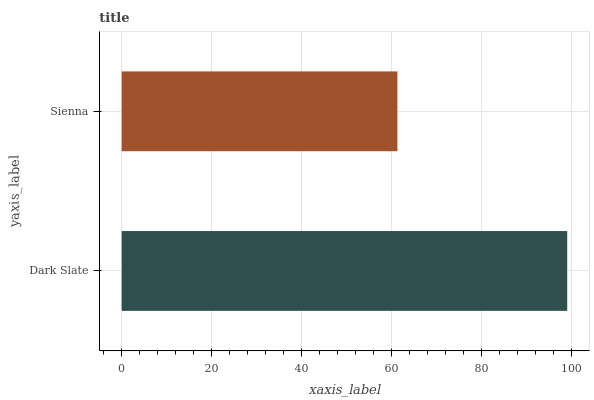Is Sienna the minimum?
Answer yes or no. Yes. Is Dark Slate the maximum?
Answer yes or no. Yes. Is Sienna the maximum?
Answer yes or no. No. Is Dark Slate greater than Sienna?
Answer yes or no. Yes. Is Sienna less than Dark Slate?
Answer yes or no. Yes. Is Sienna greater than Dark Slate?
Answer yes or no. No. Is Dark Slate less than Sienna?
Answer yes or no. No. Is Dark Slate the high median?
Answer yes or no. Yes. Is Sienna the low median?
Answer yes or no. Yes. Is Sienna the high median?
Answer yes or no. No. Is Dark Slate the low median?
Answer yes or no. No. 